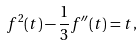<formula> <loc_0><loc_0><loc_500><loc_500>f ^ { 2 } ( t ) - \frac { 1 } { 3 } f ^ { \prime \prime } ( t ) = t ,</formula> 